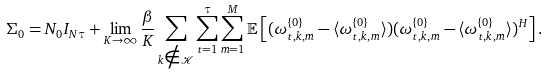Convert formula to latex. <formula><loc_0><loc_0><loc_500><loc_500>\Sigma _ { 0 } = N _ { 0 } I _ { N \tau } + \lim _ { K \rightarrow \infty } \frac { \beta } { K } \sum _ { k \notin \mathcal { K } } \sum _ { t = 1 } ^ { \tau } \sum _ { m = 1 } ^ { M } \mathbb { E } \left [ ( \omega _ { t , k , m } ^ { \{ 0 \} } - \langle \omega _ { t , k , m } ^ { \{ 0 \} } \rangle ) ( \omega _ { t , k , m } ^ { \{ 0 \} } - \langle \omega _ { t , k , m } ^ { \{ 0 \} } \rangle ) ^ { H } \right ] .</formula> 